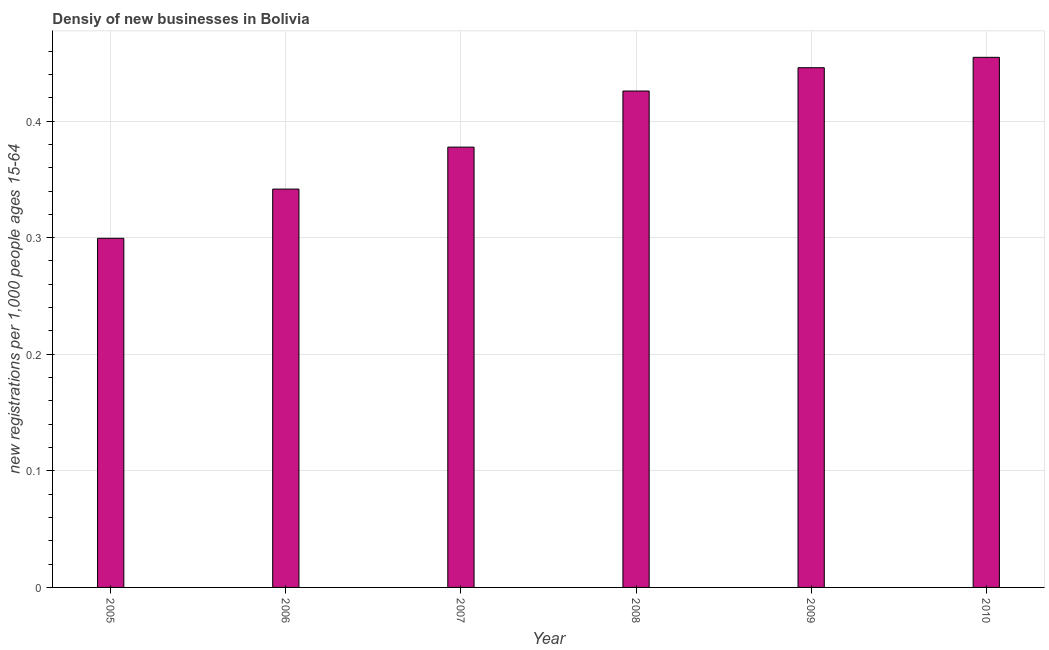What is the title of the graph?
Your response must be concise. Densiy of new businesses in Bolivia. What is the label or title of the X-axis?
Give a very brief answer. Year. What is the label or title of the Y-axis?
Give a very brief answer. New registrations per 1,0 people ages 15-64. What is the density of new business in 2010?
Your answer should be very brief. 0.45. Across all years, what is the maximum density of new business?
Make the answer very short. 0.45. Across all years, what is the minimum density of new business?
Offer a terse response. 0.3. In which year was the density of new business maximum?
Your answer should be very brief. 2010. What is the sum of the density of new business?
Keep it short and to the point. 2.35. What is the difference between the density of new business in 2007 and 2008?
Your response must be concise. -0.05. What is the average density of new business per year?
Offer a terse response. 0.39. What is the median density of new business?
Offer a very short reply. 0.4. What is the ratio of the density of new business in 2005 to that in 2010?
Your response must be concise. 0.66. Is the density of new business in 2007 less than that in 2009?
Your response must be concise. Yes. What is the difference between the highest and the second highest density of new business?
Your answer should be compact. 0.01. Is the sum of the density of new business in 2005 and 2010 greater than the maximum density of new business across all years?
Provide a short and direct response. Yes. What is the difference between the highest and the lowest density of new business?
Your answer should be compact. 0.16. How many bars are there?
Make the answer very short. 6. What is the new registrations per 1,000 people ages 15-64 of 2005?
Ensure brevity in your answer.  0.3. What is the new registrations per 1,000 people ages 15-64 of 2006?
Provide a succinct answer. 0.34. What is the new registrations per 1,000 people ages 15-64 in 2007?
Keep it short and to the point. 0.38. What is the new registrations per 1,000 people ages 15-64 of 2008?
Your answer should be compact. 0.43. What is the new registrations per 1,000 people ages 15-64 of 2009?
Your answer should be compact. 0.45. What is the new registrations per 1,000 people ages 15-64 of 2010?
Your response must be concise. 0.45. What is the difference between the new registrations per 1,000 people ages 15-64 in 2005 and 2006?
Keep it short and to the point. -0.04. What is the difference between the new registrations per 1,000 people ages 15-64 in 2005 and 2007?
Provide a short and direct response. -0.08. What is the difference between the new registrations per 1,000 people ages 15-64 in 2005 and 2008?
Offer a terse response. -0.13. What is the difference between the new registrations per 1,000 people ages 15-64 in 2005 and 2009?
Keep it short and to the point. -0.15. What is the difference between the new registrations per 1,000 people ages 15-64 in 2005 and 2010?
Offer a very short reply. -0.16. What is the difference between the new registrations per 1,000 people ages 15-64 in 2006 and 2007?
Keep it short and to the point. -0.04. What is the difference between the new registrations per 1,000 people ages 15-64 in 2006 and 2008?
Provide a succinct answer. -0.08. What is the difference between the new registrations per 1,000 people ages 15-64 in 2006 and 2009?
Give a very brief answer. -0.1. What is the difference between the new registrations per 1,000 people ages 15-64 in 2006 and 2010?
Give a very brief answer. -0.11. What is the difference between the new registrations per 1,000 people ages 15-64 in 2007 and 2008?
Offer a terse response. -0.05. What is the difference between the new registrations per 1,000 people ages 15-64 in 2007 and 2009?
Provide a succinct answer. -0.07. What is the difference between the new registrations per 1,000 people ages 15-64 in 2007 and 2010?
Provide a succinct answer. -0.08. What is the difference between the new registrations per 1,000 people ages 15-64 in 2008 and 2009?
Keep it short and to the point. -0.02. What is the difference between the new registrations per 1,000 people ages 15-64 in 2008 and 2010?
Provide a succinct answer. -0.03. What is the difference between the new registrations per 1,000 people ages 15-64 in 2009 and 2010?
Give a very brief answer. -0.01. What is the ratio of the new registrations per 1,000 people ages 15-64 in 2005 to that in 2006?
Keep it short and to the point. 0.88. What is the ratio of the new registrations per 1,000 people ages 15-64 in 2005 to that in 2007?
Your response must be concise. 0.79. What is the ratio of the new registrations per 1,000 people ages 15-64 in 2005 to that in 2008?
Your response must be concise. 0.7. What is the ratio of the new registrations per 1,000 people ages 15-64 in 2005 to that in 2009?
Your answer should be very brief. 0.67. What is the ratio of the new registrations per 1,000 people ages 15-64 in 2005 to that in 2010?
Keep it short and to the point. 0.66. What is the ratio of the new registrations per 1,000 people ages 15-64 in 2006 to that in 2007?
Your response must be concise. 0.91. What is the ratio of the new registrations per 1,000 people ages 15-64 in 2006 to that in 2008?
Provide a succinct answer. 0.8. What is the ratio of the new registrations per 1,000 people ages 15-64 in 2006 to that in 2009?
Your answer should be compact. 0.77. What is the ratio of the new registrations per 1,000 people ages 15-64 in 2006 to that in 2010?
Offer a terse response. 0.75. What is the ratio of the new registrations per 1,000 people ages 15-64 in 2007 to that in 2008?
Provide a succinct answer. 0.89. What is the ratio of the new registrations per 1,000 people ages 15-64 in 2007 to that in 2009?
Ensure brevity in your answer.  0.85. What is the ratio of the new registrations per 1,000 people ages 15-64 in 2007 to that in 2010?
Provide a succinct answer. 0.83. What is the ratio of the new registrations per 1,000 people ages 15-64 in 2008 to that in 2009?
Ensure brevity in your answer.  0.95. What is the ratio of the new registrations per 1,000 people ages 15-64 in 2008 to that in 2010?
Give a very brief answer. 0.94. 